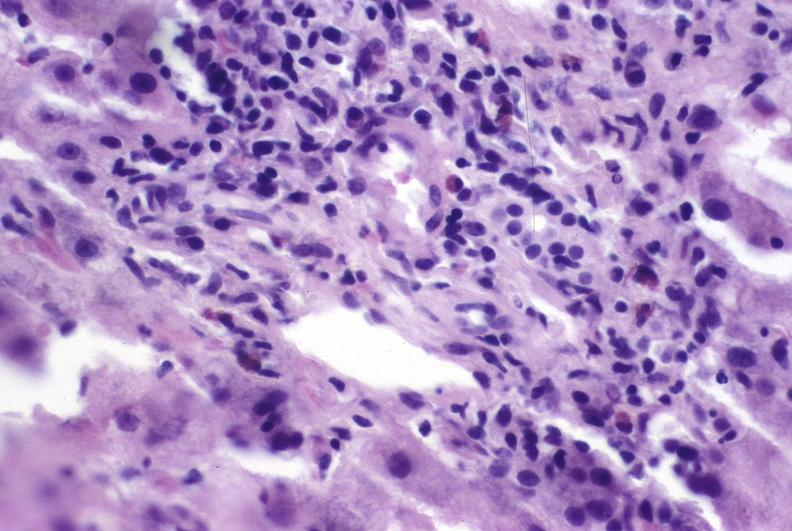what is present?
Answer the question using a single word or phrase. Liver 